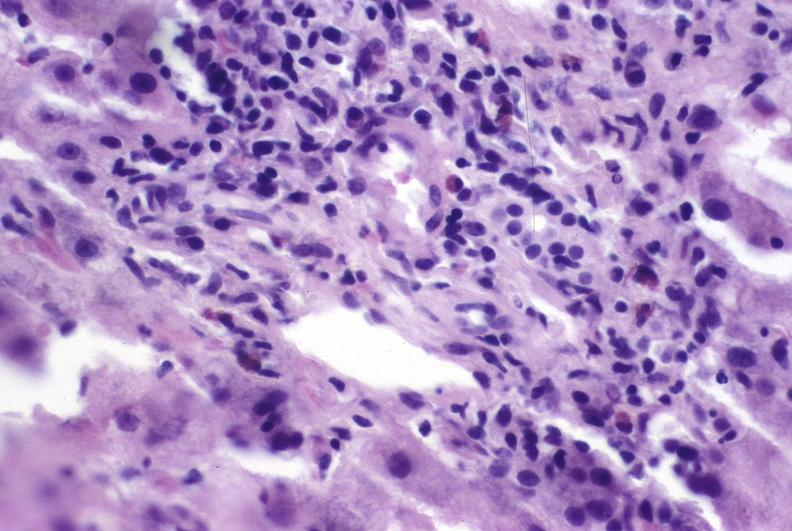what is present?
Answer the question using a single word or phrase. Liver 